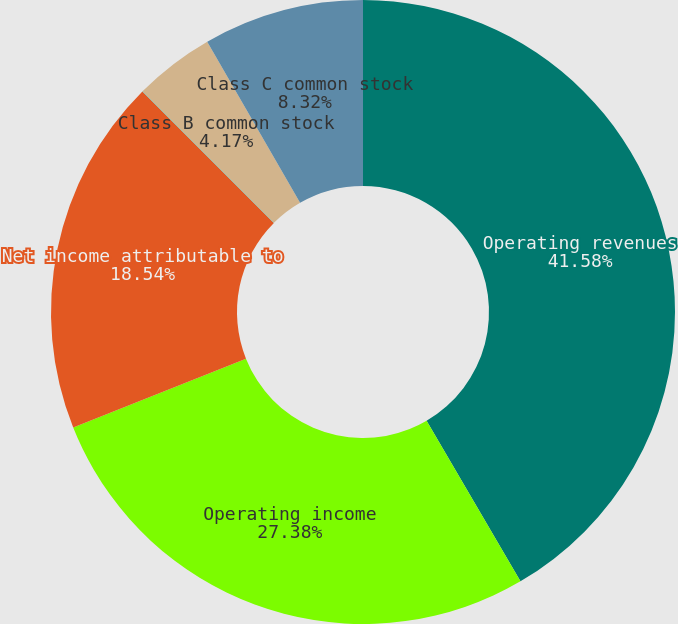Convert chart to OTSL. <chart><loc_0><loc_0><loc_500><loc_500><pie_chart><fcel>Operating revenues<fcel>Operating income<fcel>Net income attributable to<fcel>Class A common stock<fcel>Class B common stock<fcel>Class C common stock<nl><fcel>41.58%<fcel>27.38%<fcel>18.54%<fcel>0.01%<fcel>4.17%<fcel>8.32%<nl></chart> 